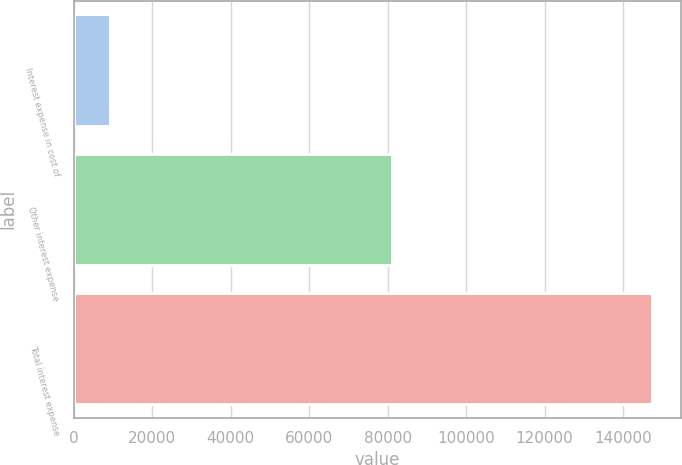Convert chart. <chart><loc_0><loc_0><loc_500><loc_500><bar_chart><fcel>Interest expense in cost of<fcel>Other interest expense<fcel>Total interest expense<nl><fcel>9185<fcel>81240.4<fcel>147449<nl></chart> 